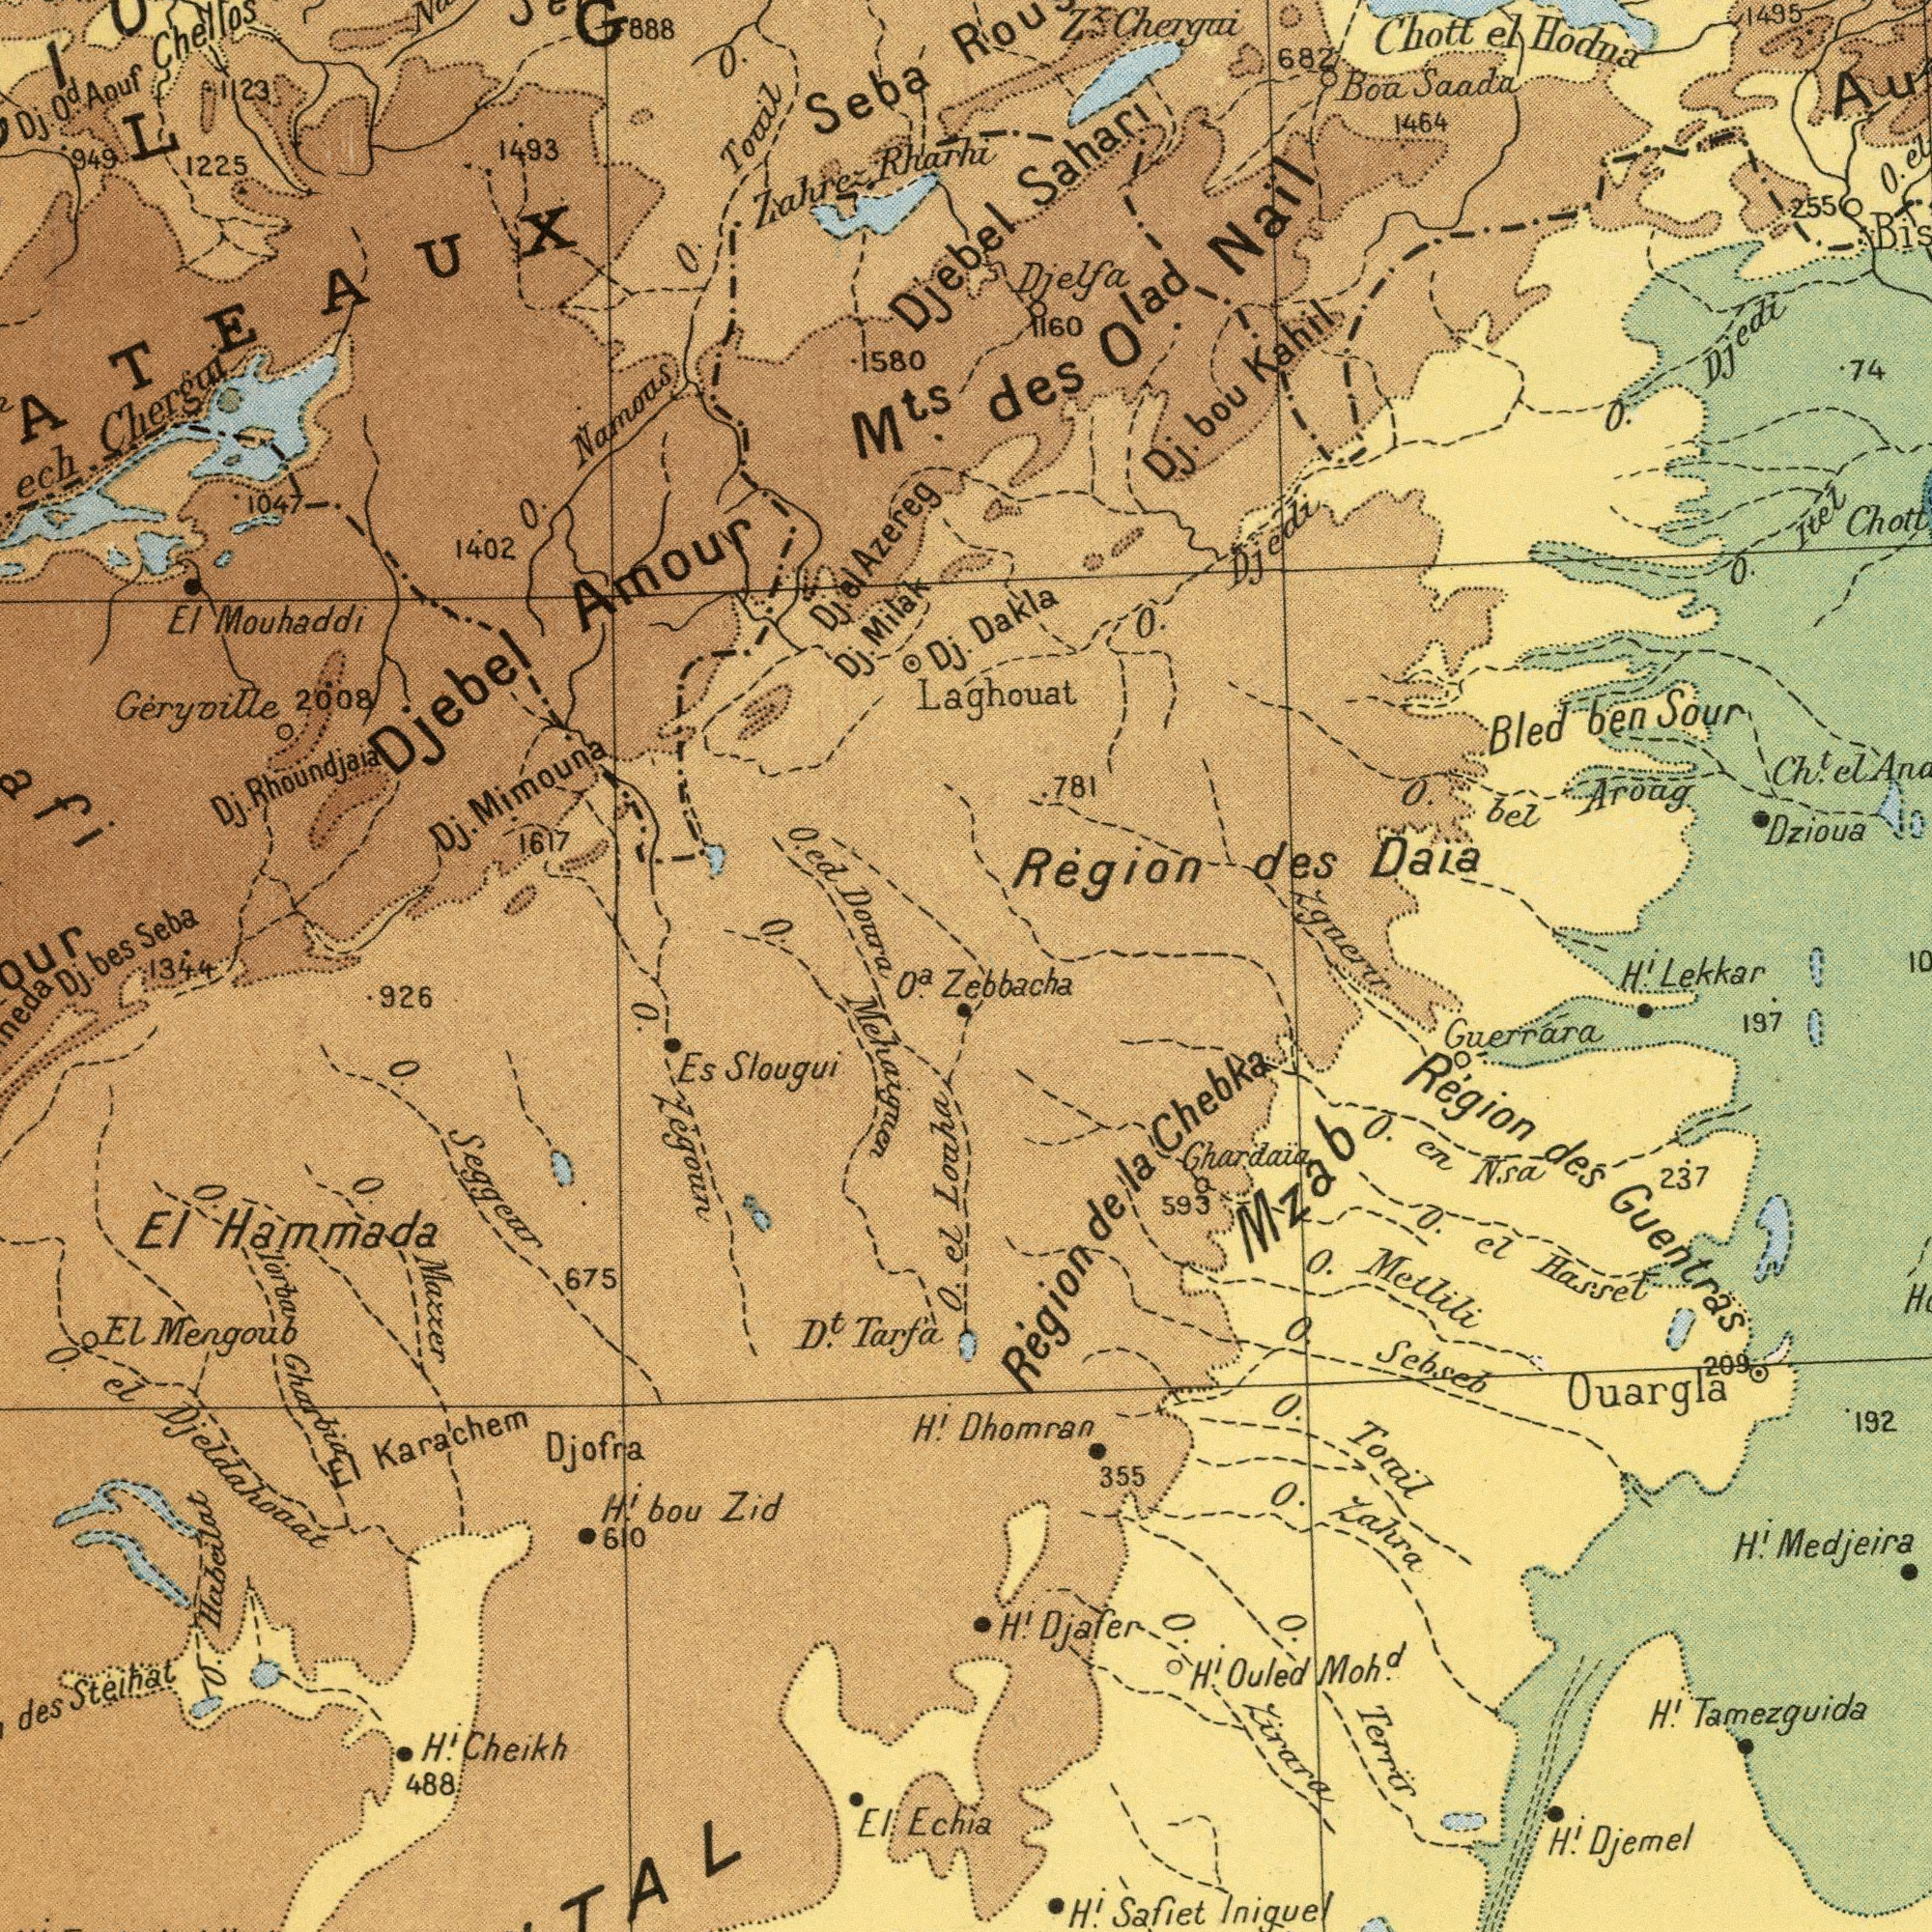What text is visible in the lower-left corner? Dj. 1344 Mehaiquen El Hammada O. Maccer El Karachem Djofra O. Kegoun O Seggear 675 Es Slougui El Mengoub D<sup>t</sup>. Tarfa des Steihat H<sup>i</sup>. bou Zid 610 H<sup>i</sup>. Cheikh 488 H.<sup>i</sup> O. el Djeldahoaat 926 El Echia O. el Louha O.<sup>a</sup> O. Torba Gharbia O. Habeilat What text can you see in the top-left section? Geryvoille 2008 L Seba O. Namous Dj. Rhoundjaia Dj. Mimouna 1617 ech. Chergai Djebel Amour O. Touil El Mouhaddi bes Seba Dj. Od Aouf Chellos Dj. Milak 1225 1580 M<sup>ts</sup>. O. ed Doura Zahrez Rharhi 1402 O. G 888 Dj el Azereg O. 1493 949 Dj. 1047 1123 ###ATEAUX Djebel What text can you see in the top-right section? des O<sup>lad</sup> Nail Laghouat 781 Dakla Sahari O. bel Aroag Boa Saada 1464 Region des Daia Chott el Hodna 1495 O. Itez Djelfa 1160 Z.<sup>z</sup> Chergui 682 Dj. bou Kahil O. Djedi O. Djedi 74 Bled ben Sour 255 O. Ch.<sup>t</sup> el Dzioua Zgaerir What text is shown in the bottom-right quadrant? Dhomran 355 Zebbacha Region des Guentras H<sup>i</sup>. Tamezguida H<sup>i</sup>. Medjeira O. Sebseb H<sup>i</sup>. Iniquel O. Toril Région de la Chebka H<sup>i</sup>. Djemel O. Zahra O. zirara Guerrára O. en Nsa 237 H<sup>i</sup>. Djafer H<sup>i</sup>. Ouled Moh<sup>d</sup>. Ouargla O. Metlili Ghardaia 593 O. Terrir Mzab H.<sup>i</sup> Lekkar 197 192 O. el Hasset 209 